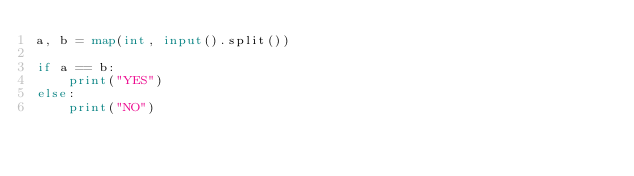<code> <loc_0><loc_0><loc_500><loc_500><_Python_>a, b = map(int, input().split())

if a == b:
    print("YES")
else:
    print("NO")</code> 